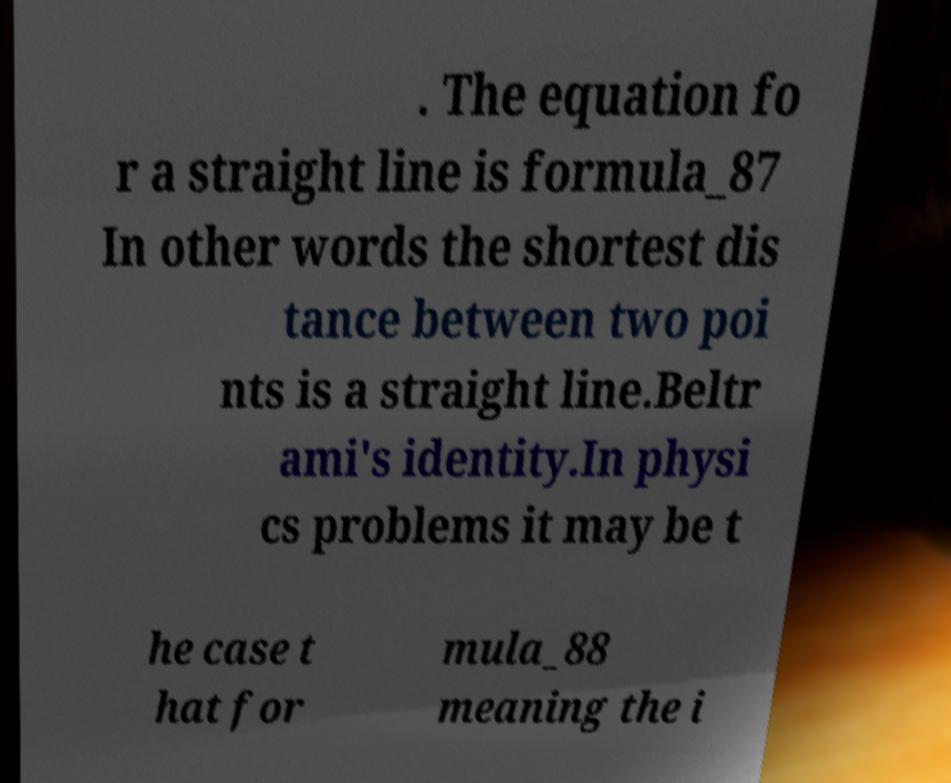Please identify and transcribe the text found in this image. . The equation fo r a straight line is formula_87 In other words the shortest dis tance between two poi nts is a straight line.Beltr ami's identity.In physi cs problems it may be t he case t hat for mula_88 meaning the i 